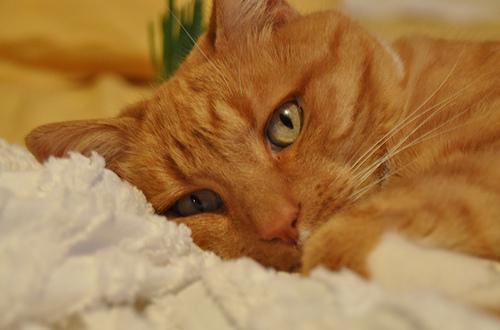Is the cat running?
Quick response, please. No. Does the kitten look tired?
Write a very short answer. Yes. What color is the kitty?
Concise answer only. Orange. What breed of cat is it?
Short answer required. Tabby. What color is the bedding?
Answer briefly. White. 